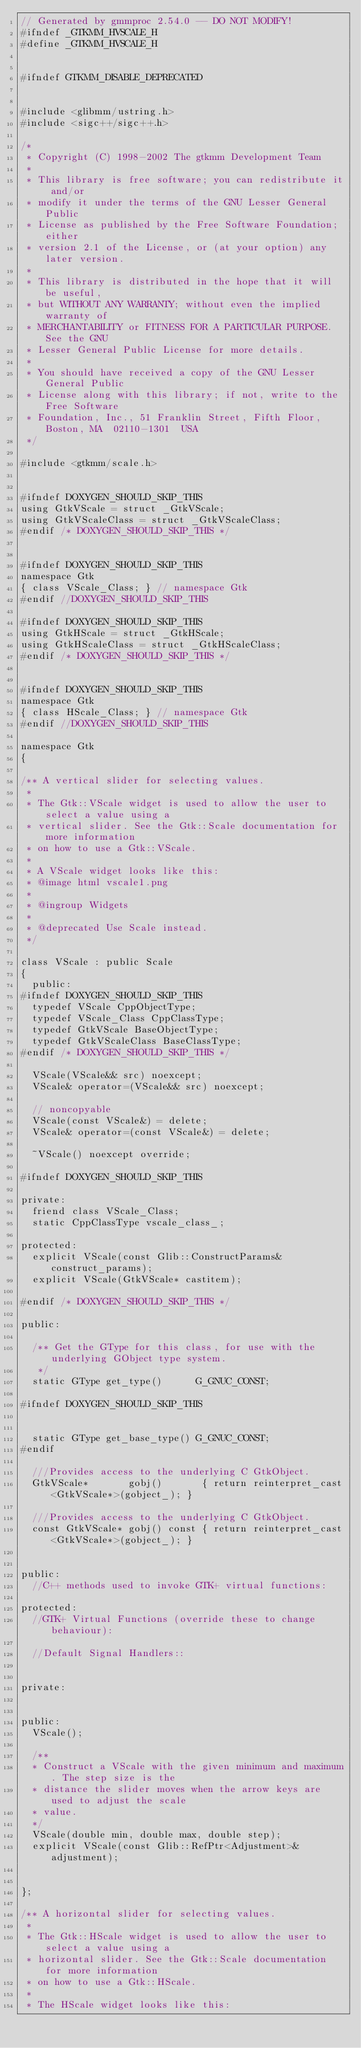Convert code to text. <code><loc_0><loc_0><loc_500><loc_500><_C_>// Generated by gmmproc 2.54.0 -- DO NOT MODIFY!
#ifndef _GTKMM_HVSCALE_H
#define _GTKMM_HVSCALE_H


#ifndef GTKMM_DISABLE_DEPRECATED


#include <glibmm/ustring.h>
#include <sigc++/sigc++.h>

/*
 * Copyright (C) 1998-2002 The gtkmm Development Team
 *
 * This library is free software; you can redistribute it and/or
 * modify it under the terms of the GNU Lesser General Public
 * License as published by the Free Software Foundation; either
 * version 2.1 of the License, or (at your option) any later version.
 *
 * This library is distributed in the hope that it will be useful,
 * but WITHOUT ANY WARRANTY; without even the implied warranty of
 * MERCHANTABILITY or FITNESS FOR A PARTICULAR PURPOSE.  See the GNU
 * Lesser General Public License for more details.
 *
 * You should have received a copy of the GNU Lesser General Public
 * License along with this library; if not, write to the Free Software
 * Foundation, Inc., 51 Franklin Street, Fifth Floor, Boston, MA  02110-1301  USA
 */

#include <gtkmm/scale.h>


#ifndef DOXYGEN_SHOULD_SKIP_THIS
using GtkVScale = struct _GtkVScale;
using GtkVScaleClass = struct _GtkVScaleClass;
#endif /* DOXYGEN_SHOULD_SKIP_THIS */


#ifndef DOXYGEN_SHOULD_SKIP_THIS
namespace Gtk
{ class VScale_Class; } // namespace Gtk
#endif //DOXYGEN_SHOULD_SKIP_THIS

#ifndef DOXYGEN_SHOULD_SKIP_THIS
using GtkHScale = struct _GtkHScale;
using GtkHScaleClass = struct _GtkHScaleClass;
#endif /* DOXYGEN_SHOULD_SKIP_THIS */


#ifndef DOXYGEN_SHOULD_SKIP_THIS
namespace Gtk
{ class HScale_Class; } // namespace Gtk
#endif //DOXYGEN_SHOULD_SKIP_THIS

namespace Gtk
{

/** A vertical slider for selecting values.
 *
 * The Gtk::VScale widget is used to allow the user to select a value using a
 * vertical slider. See the Gtk::Scale documentation for more information
 * on how to use a Gtk::VScale.
 *
 * A VScale widget looks like this:
 * @image html vscale1.png
 *
 * @ingroup Widgets
 *
 * @deprecated Use Scale instead.
 */

class VScale : public Scale
{
  public:
#ifndef DOXYGEN_SHOULD_SKIP_THIS
  typedef VScale CppObjectType;
  typedef VScale_Class CppClassType;
  typedef GtkVScale BaseObjectType;
  typedef GtkVScaleClass BaseClassType;
#endif /* DOXYGEN_SHOULD_SKIP_THIS */

  VScale(VScale&& src) noexcept;
  VScale& operator=(VScale&& src) noexcept;

  // noncopyable
  VScale(const VScale&) = delete;
  VScale& operator=(const VScale&) = delete;

  ~VScale() noexcept override;

#ifndef DOXYGEN_SHOULD_SKIP_THIS

private:
  friend class VScale_Class;
  static CppClassType vscale_class_;

protected:
  explicit VScale(const Glib::ConstructParams& construct_params);
  explicit VScale(GtkVScale* castitem);

#endif /* DOXYGEN_SHOULD_SKIP_THIS */

public:

  /** Get the GType for this class, for use with the underlying GObject type system.
   */
  static GType get_type()      G_GNUC_CONST;

#ifndef DOXYGEN_SHOULD_SKIP_THIS


  static GType get_base_type() G_GNUC_CONST;
#endif

  ///Provides access to the underlying C GtkObject.
  GtkVScale*       gobj()       { return reinterpret_cast<GtkVScale*>(gobject_); }

  ///Provides access to the underlying C GtkObject.
  const GtkVScale* gobj() const { return reinterpret_cast<GtkVScale*>(gobject_); }


public:
  //C++ methods used to invoke GTK+ virtual functions:

protected:
  //GTK+ Virtual Functions (override these to change behaviour):

  //Default Signal Handlers::


private:

  
public:
  VScale();

  /**
  * Construct a VScale with the given minimum and maximum. The step size is the
  * distance the slider moves when the arrow keys are used to adjust the scale
  * value.
  */
  VScale(double min, double max, double step);
  explicit VScale(const Glib::RefPtr<Adjustment>& adjustment);


};

/** A horizontal slider for selecting values.
 *
 * The Gtk::HScale widget is used to allow the user to select a value using a
 * horizontal slider. See the Gtk::Scale documentation for more information
 * on how to use a Gtk::HScale.
 *
 * The HScale widget looks like this:</code> 